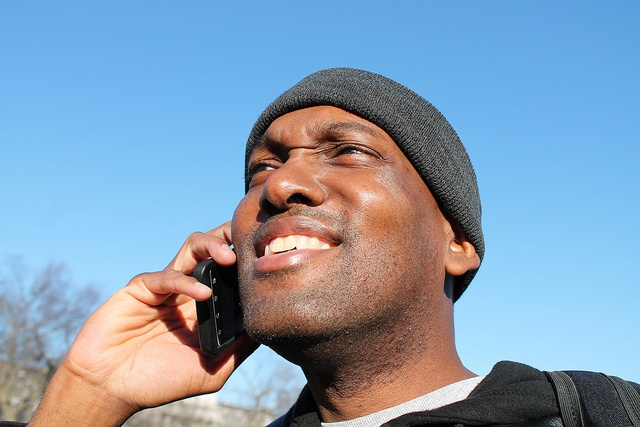Describe the objects in this image and their specific colors. I can see people in lightblue, black, brown, salmon, and gray tones and cell phone in lightblue, black, gray, maroon, and purple tones in this image. 